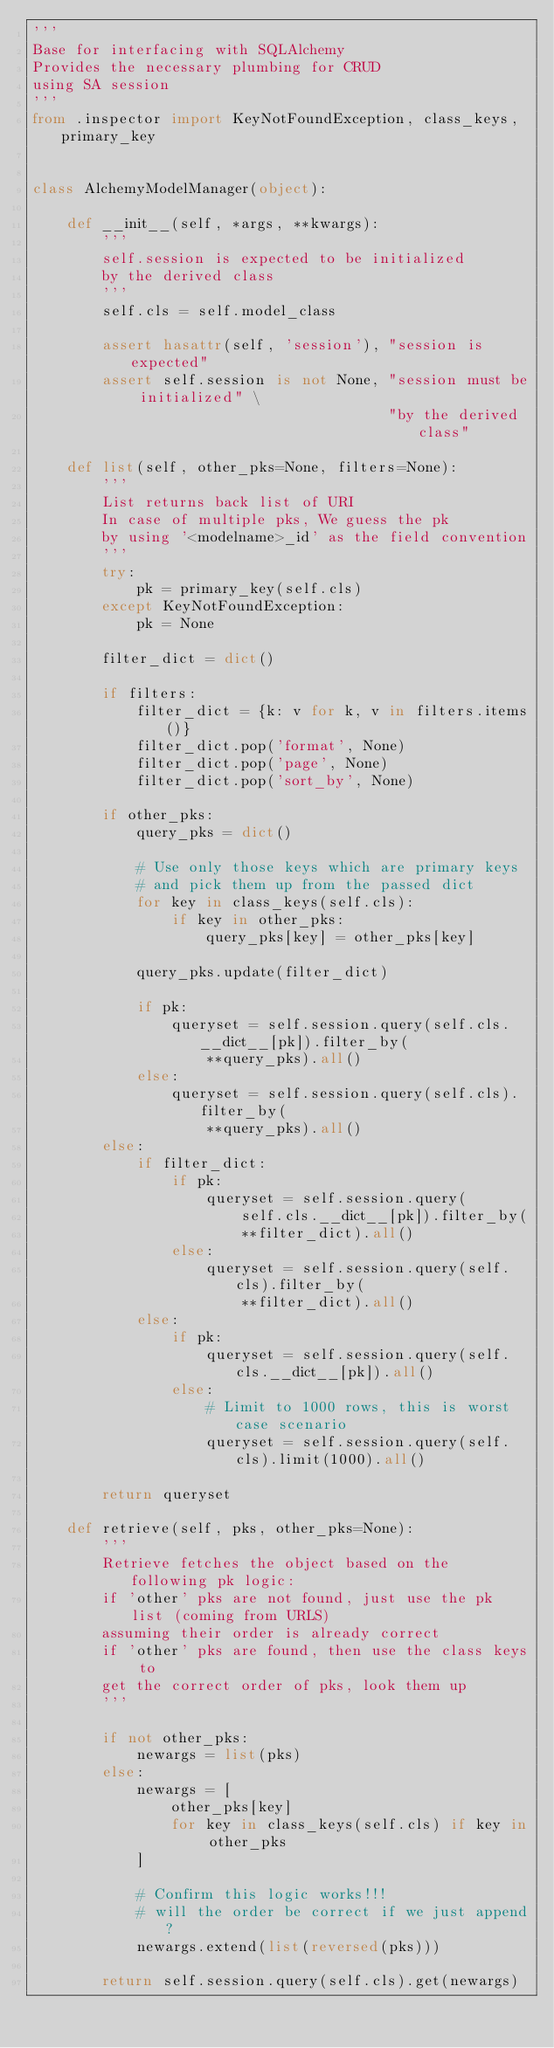Convert code to text. <code><loc_0><loc_0><loc_500><loc_500><_Python_>'''
Base for interfacing with SQLAlchemy
Provides the necessary plumbing for CRUD
using SA session
'''
from .inspector import KeyNotFoundException, class_keys, primary_key


class AlchemyModelManager(object):

    def __init__(self, *args, **kwargs):
        '''
        self.session is expected to be initialized
        by the derived class
        '''
        self.cls = self.model_class

        assert hasattr(self, 'session'), "session is expected"
        assert self.session is not None, "session must be initialized" \
                                         "by the derived class"

    def list(self, other_pks=None, filters=None):
        '''
        List returns back list of URI
        In case of multiple pks, We guess the pk
        by using '<modelname>_id' as the field convention
        '''
        try:
            pk = primary_key(self.cls)
        except KeyNotFoundException:
            pk = None

        filter_dict = dict()

        if filters:
            filter_dict = {k: v for k, v in filters.items()}
            filter_dict.pop('format', None)
            filter_dict.pop('page', None)
            filter_dict.pop('sort_by', None)

        if other_pks:
            query_pks = dict()

            # Use only those keys which are primary keys
            # and pick them up from the passed dict
            for key in class_keys(self.cls):
                if key in other_pks:
                    query_pks[key] = other_pks[key]

            query_pks.update(filter_dict)

            if pk:
                queryset = self.session.query(self.cls.__dict__[pk]).filter_by(
                    **query_pks).all()
            else:
                queryset = self.session.query(self.cls).filter_by(
                    **query_pks).all()
        else:
            if filter_dict:
                if pk:
                    queryset = self.session.query(
                        self.cls.__dict__[pk]).filter_by(
                        **filter_dict).all()
                else:
                    queryset = self.session.query(self.cls).filter_by(
                        **filter_dict).all()
            else:
                if pk:
                    queryset = self.session.query(self.cls.__dict__[pk]).all()
                else:
                    # Limit to 1000 rows, this is worst case scenario
                    queryset = self.session.query(self.cls).limit(1000).all()

        return queryset

    def retrieve(self, pks, other_pks=None):
        '''
        Retrieve fetches the object based on the following pk logic:
        if 'other' pks are not found, just use the pk list (coming from URLS)
        assuming their order is already correct
        if 'other' pks are found, then use the class keys to
        get the correct order of pks, look them up
        '''

        if not other_pks:
            newargs = list(pks)
        else:
            newargs = [
                other_pks[key]
                for key in class_keys(self.cls) if key in other_pks
            ]

            # Confirm this logic works!!!
            # will the order be correct if we just append?
            newargs.extend(list(reversed(pks)))

        return self.session.query(self.cls).get(newargs)
</code> 